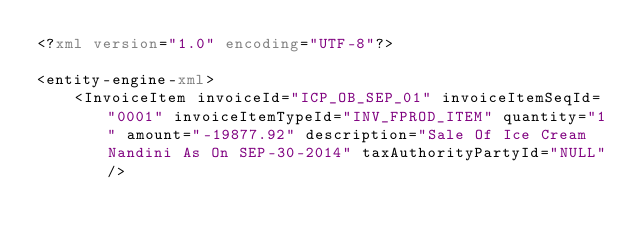<code> <loc_0><loc_0><loc_500><loc_500><_XML_><?xml version="1.0" encoding="UTF-8"?>

<entity-engine-xml>
    <InvoiceItem invoiceId="ICP_OB_SEP_01" invoiceItemSeqId="0001" invoiceItemTypeId="INV_FPROD_ITEM" quantity="1" amount="-19877.92" description="Sale Of Ice Cream Nandini As On SEP-30-2014" taxAuthorityPartyId="NULL"/></code> 